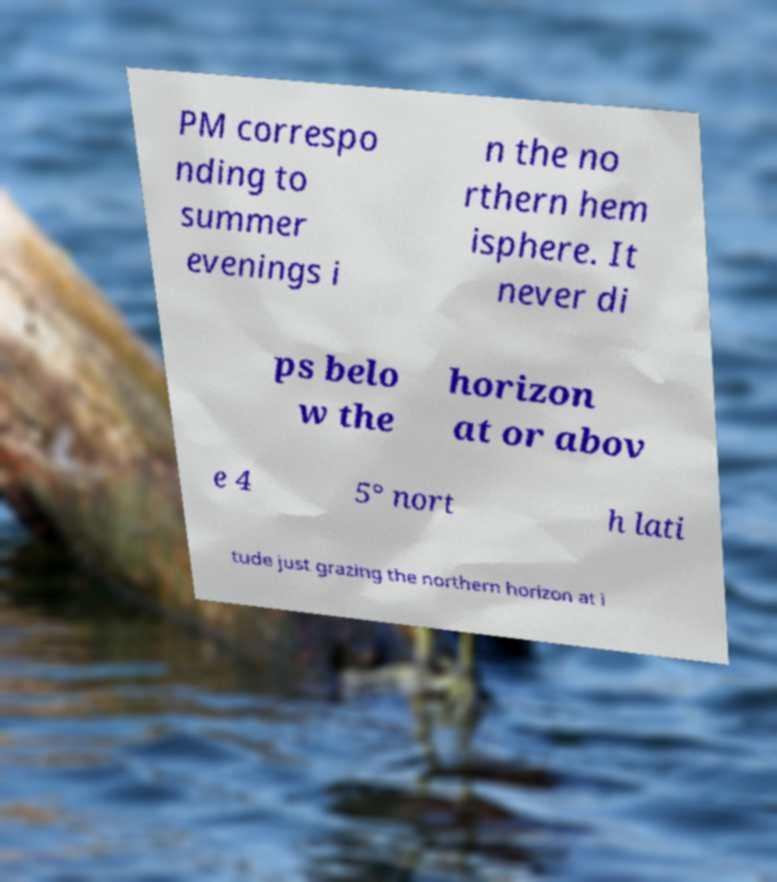Could you assist in decoding the text presented in this image and type it out clearly? PM correspo nding to summer evenings i n the no rthern hem isphere. It never di ps belo w the horizon at or abov e 4 5° nort h lati tude just grazing the northern horizon at i 